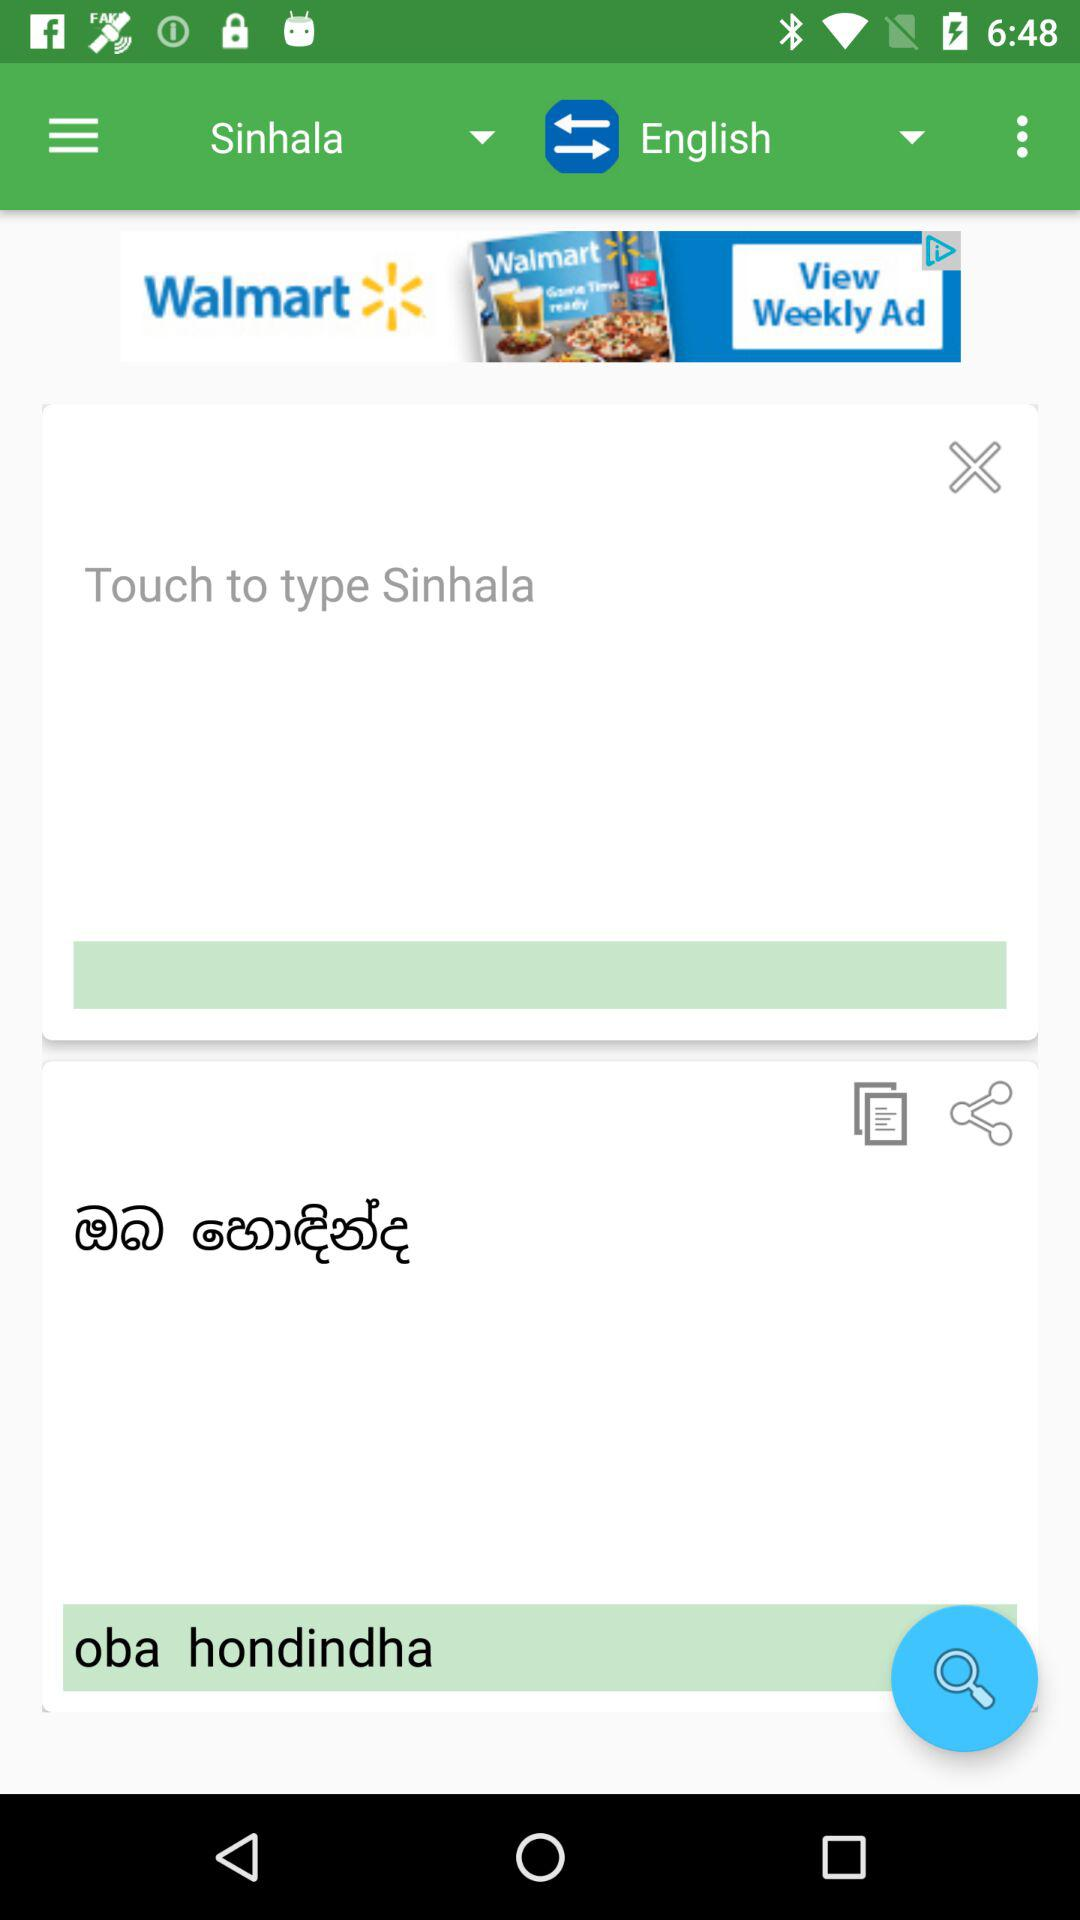How many translations can be done for free?
When the provided information is insufficient, respond with <no answer>. <no answer> 